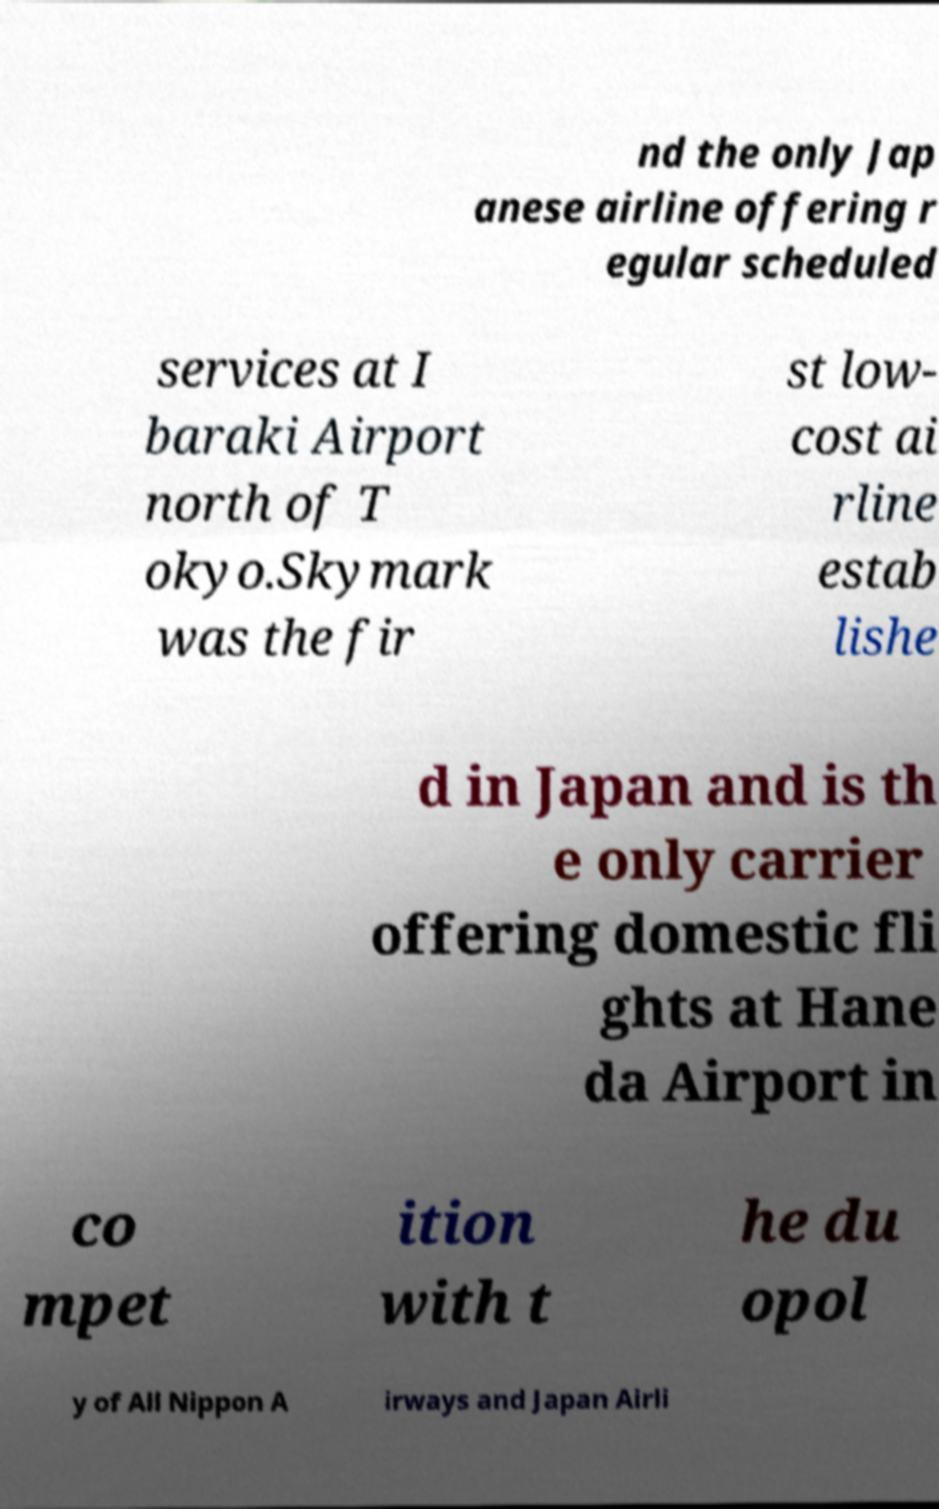Please read and relay the text visible in this image. What does it say? nd the only Jap anese airline offering r egular scheduled services at I baraki Airport north of T okyo.Skymark was the fir st low- cost ai rline estab lishe d in Japan and is th e only carrier offering domestic fli ghts at Hane da Airport in co mpet ition with t he du opol y of All Nippon A irways and Japan Airli 